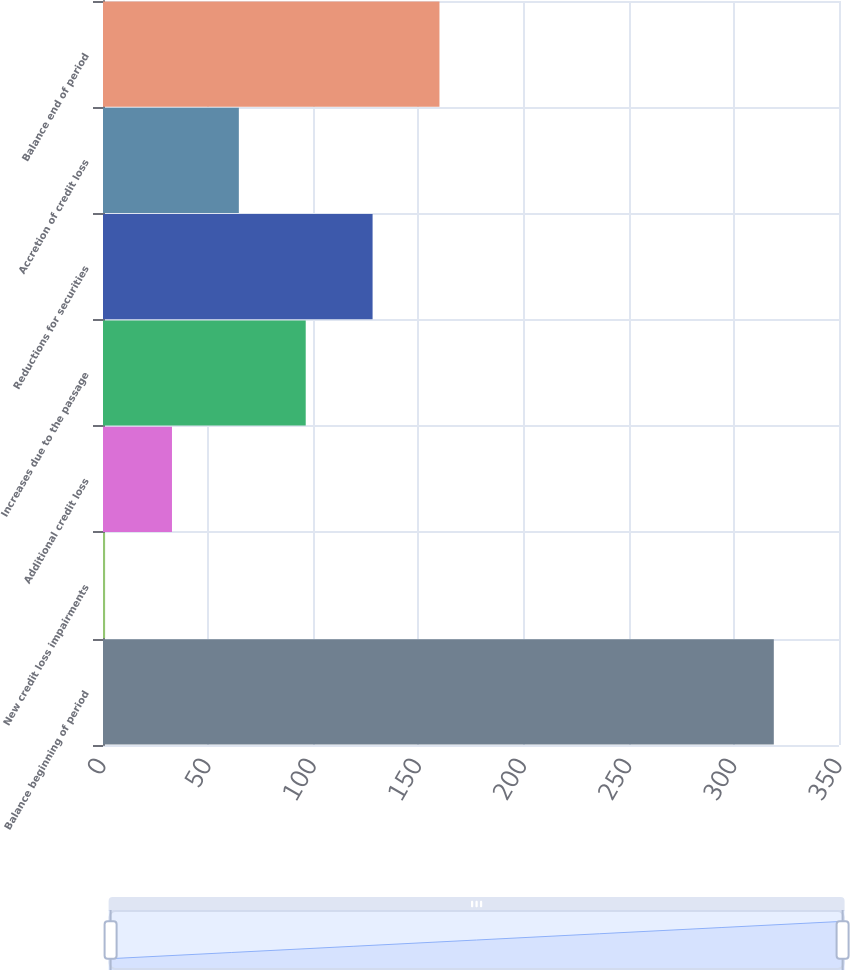Convert chart to OTSL. <chart><loc_0><loc_0><loc_500><loc_500><bar_chart><fcel>Balance beginning of period<fcel>New credit loss impairments<fcel>Additional credit loss<fcel>Increases due to the passage<fcel>Reductions for securities<fcel>Accretion of credit loss<fcel>Balance end of period<nl><fcel>319<fcel>1<fcel>32.8<fcel>96.4<fcel>128.2<fcel>64.6<fcel>160<nl></chart> 